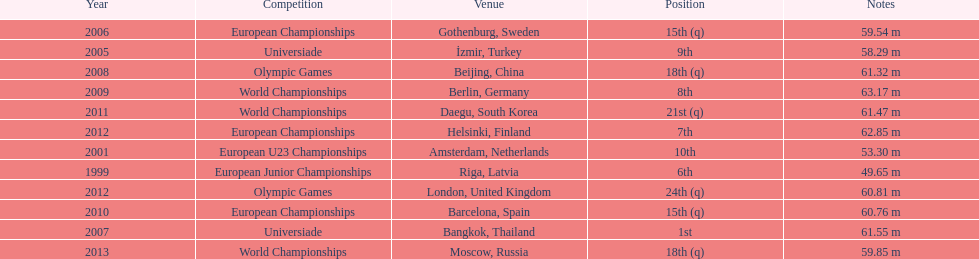What was the last competition he was in before the 2012 olympics? European Championships. 